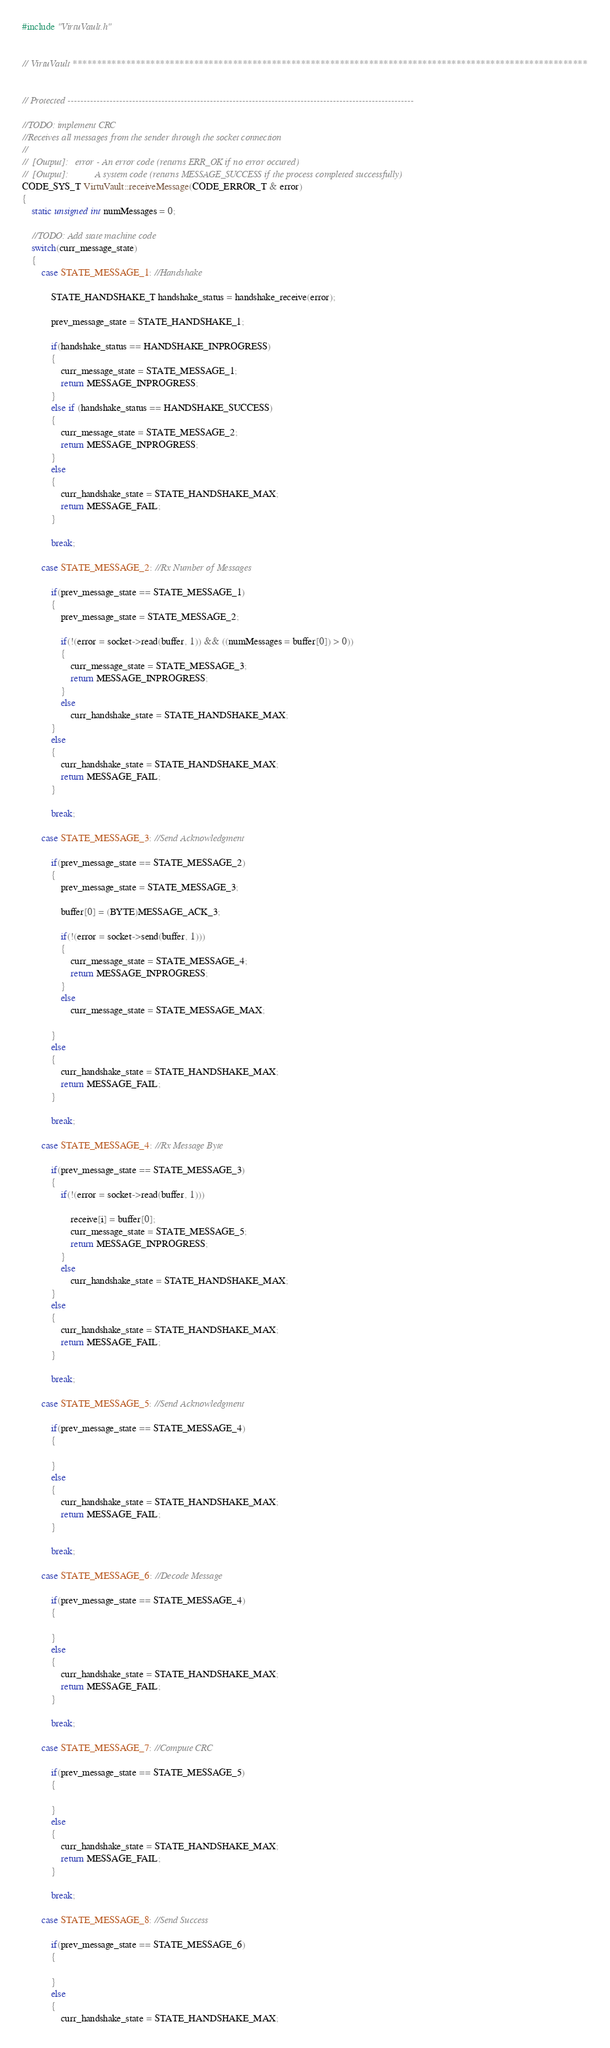Convert code to text. <code><loc_0><loc_0><loc_500><loc_500><_C++_>#include "VirtuVault.h"


// VirtuVault **********************************************************************************************************


// Protected -----------------------------------------------------------------------------------------------------------

//TODO: implement CRC
//Receives all messages from the sender through the socket connection
//
//	[Output]:	error -	An error code (returns ERR_OK if no error occured)
//	[Output]:			A system code (returns MESSAGE_SUCCESS if the process completed successfully)
CODE_SYS_T VirtuVault::receiveMessage(CODE_ERROR_T & error)
{
	static unsigned int numMessages = 0;
	
	//TODO: Add state machine code
	switch(curr_message_state)
	{
		case STATE_MESSAGE_1: //Handshake
			
			STATE_HANDSHAKE_T handshake_status = handshake_receive(error);
			
			prev_message_state = STATE_HANDSHAKE_1;
			
			if(handshake_status == HANDSHAKE_INPROGRESS)
			{
				curr_message_state = STATE_MESSAGE_1;
				return MESSAGE_INPROGRESS;
			}
			else if (handshake_status == HANDSHAKE_SUCCESS)
			{
				curr_message_state = STATE_MESSAGE_2;
				return MESSAGE_INPROGRESS;
			}
			else
			{
				curr_handshake_state = STATE_HANDSHAKE_MAX;
				return MESSAGE_FAIL;
			}
			
			break;
			
		case STATE_MESSAGE_2: //Rx Number of Messages
			
			if(prev_message_state == STATE_MESSAGE_1)
			{
				prev_message_state = STATE_MESSAGE_2;
				
				if(!(error = socket->read(buffer, 1)) && ((numMessages = buffer[0]) > 0))
				{
					curr_message_state = STATE_MESSAGE_3;
					return MESSAGE_INPROGRESS;
				}
				else
					curr_handshake_state = STATE_HANDSHAKE_MAX;
			}
			else
			{
				curr_handshake_state = STATE_HANDSHAKE_MAX;
				return MESSAGE_FAIL;
			}
			
			break;
			
		case STATE_MESSAGE_3: //Send Acknowledgment
		
			if(prev_message_state == STATE_MESSAGE_2)
			{
				prev_message_state = STATE_MESSAGE_3;
				
				buffer[0] = (BYTE)MESSAGE_ACK_3;
				
				if(!(error = socket->send(buffer, 1)))
				{
					curr_message_state = STATE_MESSAGE_4;
					return MESSAGE_INPROGRESS;
				}
				else
					curr_message_state = STATE_MESSAGE_MAX;
				
			}
			else
			{
				curr_handshake_state = STATE_HANDSHAKE_MAX;
				return MESSAGE_FAIL;
			}
			
			break;
			
		case STATE_MESSAGE_4: //Rx Message Byte
			
			if(prev_message_state == STATE_MESSAGE_3)
			{
				if(!(error = socket->read(buffer, 1)))
					
					receive[i] = buffer[0];
					curr_message_state = STATE_MESSAGE_5;
					return MESSAGE_INPROGRESS;
				}
				else
					curr_handshake_state = STATE_HANDSHAKE_MAX;
			}
			else
			{
				curr_handshake_state = STATE_HANDSHAKE_MAX;
				return MESSAGE_FAIL;
			}
			
			break;
			
		case STATE_MESSAGE_5: //Send Acknowledgment
			
			if(prev_message_state == STATE_MESSAGE_4)
			{
				
			}
			else
			{
				curr_handshake_state = STATE_HANDSHAKE_MAX;
				return MESSAGE_FAIL;
			}
			
			break;
			
		case STATE_MESSAGE_6: //Decode Message
			
			if(prev_message_state == STATE_MESSAGE_4)
			{
				
			}
			else
			{
				curr_handshake_state = STATE_HANDSHAKE_MAX;
				return MESSAGE_FAIL;
			}
			
			break;
			
		case STATE_MESSAGE_7: //Compute CRC
			
			if(prev_message_state == STATE_MESSAGE_5)
			{
				
			}
			else
			{
				curr_handshake_state = STATE_HANDSHAKE_MAX;
				return MESSAGE_FAIL;
			}
			
			break;
			
		case STATE_MESSAGE_8: //Send Success
			
			if(prev_message_state == STATE_MESSAGE_6)
			{
				
			}
			else
			{
				curr_handshake_state = STATE_HANDSHAKE_MAX;</code> 